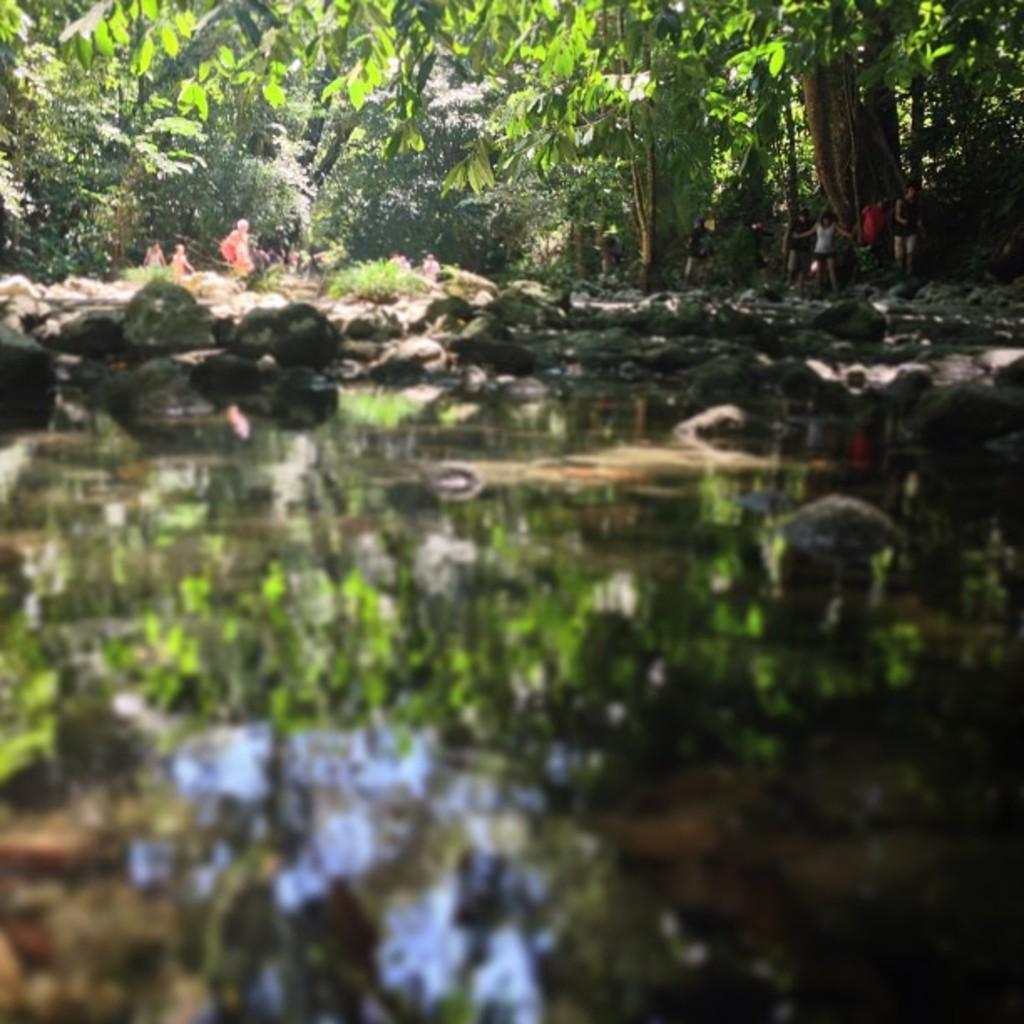Could you give a brief overview of what you see in this image? In this image there is a pond in the bottom of this image and there are some stones in the middle of this image. There are some persons standing on the right side of this image. There are some trees in the background. 